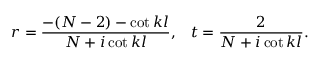Convert formula to latex. <formula><loc_0><loc_0><loc_500><loc_500>r = { \frac { - ( N - 2 ) - c o t \, k l } { N + i \, c o t \, k l } } , \, t = { \frac { 2 } { N + i \, c o t \, k l } } .</formula> 